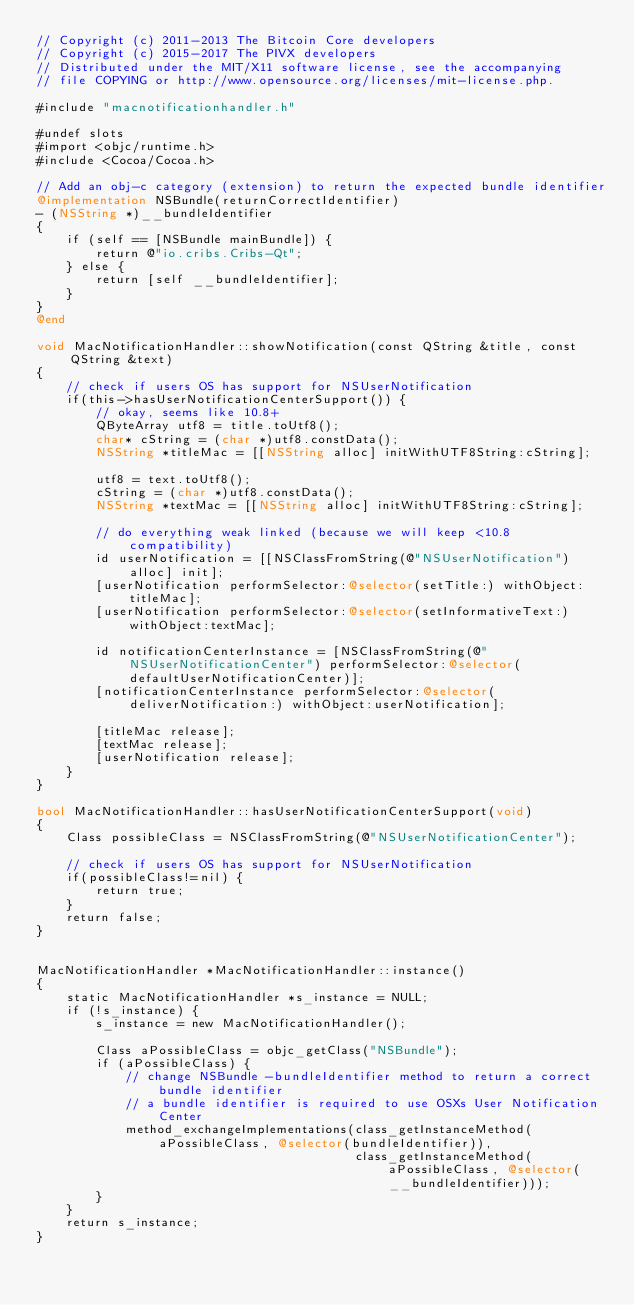<code> <loc_0><loc_0><loc_500><loc_500><_ObjectiveC_>// Copyright (c) 2011-2013 The Bitcoin Core developers
// Copyright (c) 2015-2017 The PIVX developers
// Distributed under the MIT/X11 software license, see the accompanying
// file COPYING or http://www.opensource.org/licenses/mit-license.php.

#include "macnotificationhandler.h"

#undef slots
#import <objc/runtime.h>
#include <Cocoa/Cocoa.h>

// Add an obj-c category (extension) to return the expected bundle identifier
@implementation NSBundle(returnCorrectIdentifier)
- (NSString *)__bundleIdentifier
{
    if (self == [NSBundle mainBundle]) {
        return @"io.cribs.Cribs-Qt";
    } else {
        return [self __bundleIdentifier];
    }
}
@end

void MacNotificationHandler::showNotification(const QString &title, const QString &text)
{
    // check if users OS has support for NSUserNotification
    if(this->hasUserNotificationCenterSupport()) {
        // okay, seems like 10.8+
        QByteArray utf8 = title.toUtf8();
        char* cString = (char *)utf8.constData();
        NSString *titleMac = [[NSString alloc] initWithUTF8String:cString];

        utf8 = text.toUtf8();
        cString = (char *)utf8.constData();
        NSString *textMac = [[NSString alloc] initWithUTF8String:cString];

        // do everything weak linked (because we will keep <10.8 compatibility)
        id userNotification = [[NSClassFromString(@"NSUserNotification") alloc] init];
        [userNotification performSelector:@selector(setTitle:) withObject:titleMac];
        [userNotification performSelector:@selector(setInformativeText:) withObject:textMac];

        id notificationCenterInstance = [NSClassFromString(@"NSUserNotificationCenter") performSelector:@selector(defaultUserNotificationCenter)];
        [notificationCenterInstance performSelector:@selector(deliverNotification:) withObject:userNotification];

        [titleMac release];
        [textMac release];
        [userNotification release];
    }
}

bool MacNotificationHandler::hasUserNotificationCenterSupport(void)
{
    Class possibleClass = NSClassFromString(@"NSUserNotificationCenter");

    // check if users OS has support for NSUserNotification
    if(possibleClass!=nil) {
        return true;
    }
    return false;
}


MacNotificationHandler *MacNotificationHandler::instance()
{
    static MacNotificationHandler *s_instance = NULL;
    if (!s_instance) {
        s_instance = new MacNotificationHandler();
        
        Class aPossibleClass = objc_getClass("NSBundle");
        if (aPossibleClass) {
            // change NSBundle -bundleIdentifier method to return a correct bundle identifier
            // a bundle identifier is required to use OSXs User Notification Center
            method_exchangeImplementations(class_getInstanceMethod(aPossibleClass, @selector(bundleIdentifier)),
                                           class_getInstanceMethod(aPossibleClass, @selector(__bundleIdentifier)));
        }
    }
    return s_instance;
}
</code> 